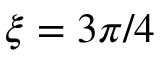<formula> <loc_0><loc_0><loc_500><loc_500>\xi = 3 \pi / 4</formula> 